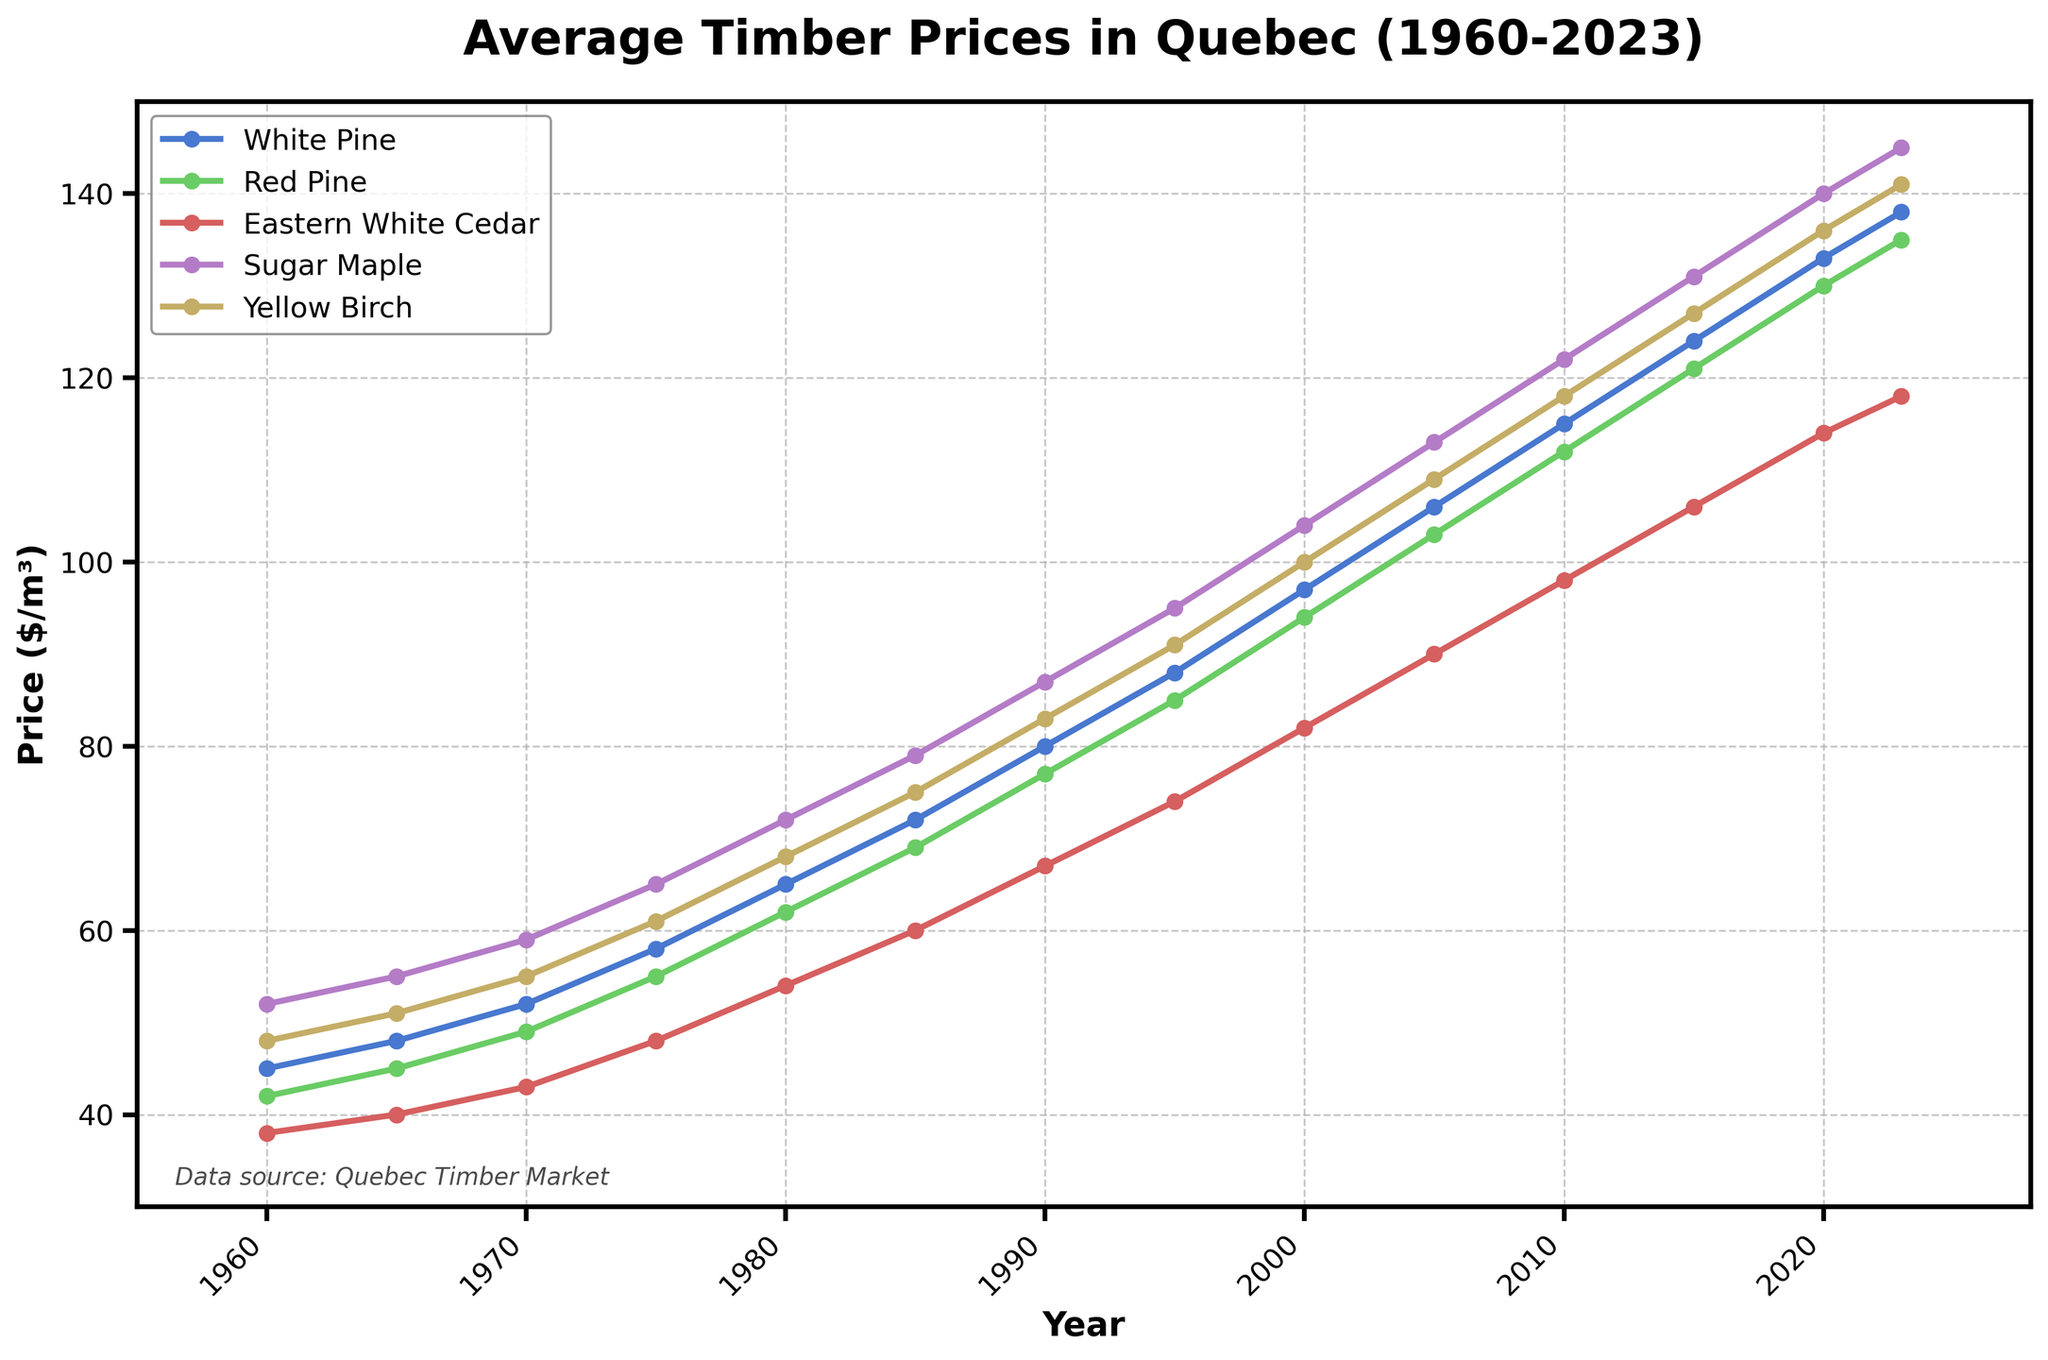Which wood species had the highest price in 2023? To answer this question, look at the end of the lines for each wood species and check the price values in 2023. The wood species with the highest price is identified.
Answer: Sugar Maple What is the difference in price between White Pine and Red Pine in 1980? Locate the points for White Pine and Red Pine at the year 1980 on the chart. Subtract the price of Red Pine from the price of White Pine to find the difference.
Answer: 3 Which wood species experienced the greatest increase in price between 1960 to 2023? Consider the start and end points of each line representing different wood species. Calculate the price increase for each wood species and compare them to identify which one had the greatest increase.
Answer: Sugar Maple Was there any year where Eastern White Cedar had a higher price than Yellow Birch? Compare the lines representing Eastern White Cedar and Yellow Birch over the years. Check if there was any point where the Eastern White Cedar line is above the Yellow Birch line.
Answer: No How many wood species had prices greater than $100 in 2023? At the year 2023 on the x-axis, check the y-values for each wood species. Count how many of those values are greater than $100.
Answer: 5 Compare the price trends of White Pine and Sugar Maple over the period of 1960 to 2023. Which species showed a more consistent increase in price? Look at the lines for White Pine and Sugar Maple. Assess the smoothness and increment rate of each line. The one with fewer fluctuations and a steady increase indicates a more consistent trend.
Answer: White Pine What was the average price of Red Pine between 1960 and 2023? Sum the Red Pine prices from each year listed and divide by the total number of data points (14) to find the average price.
Answer: 89.14 